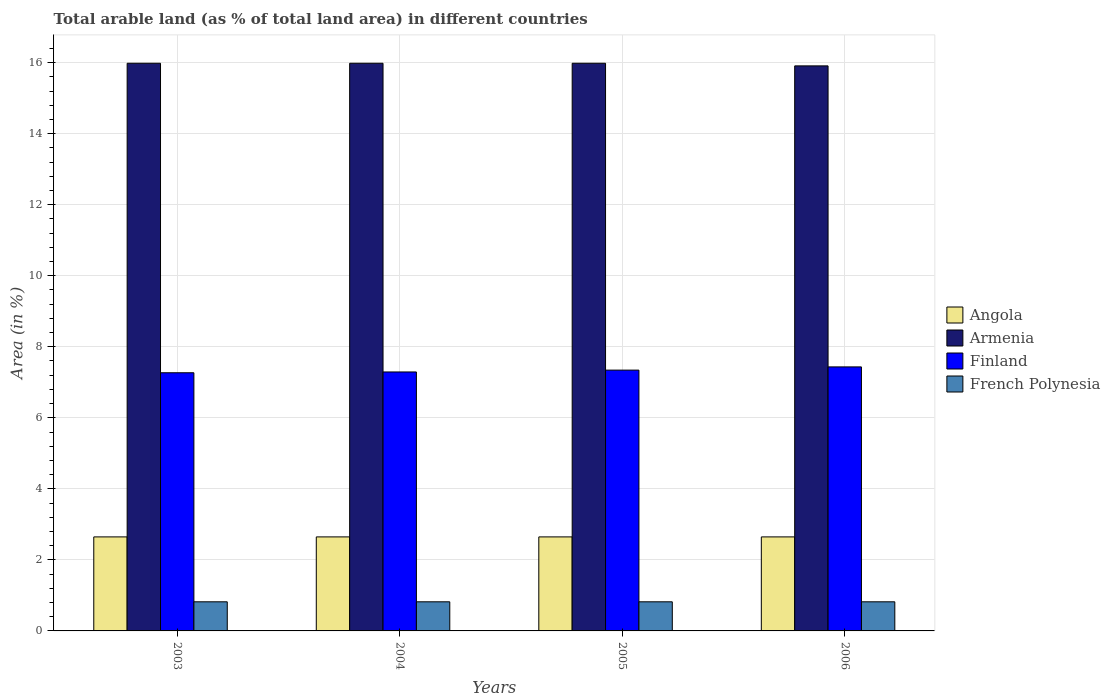Are the number of bars on each tick of the X-axis equal?
Give a very brief answer. Yes. How many bars are there on the 1st tick from the left?
Keep it short and to the point. 4. How many bars are there on the 1st tick from the right?
Ensure brevity in your answer.  4. What is the label of the 4th group of bars from the left?
Offer a terse response. 2006. What is the percentage of arable land in Armenia in 2004?
Keep it short and to the point. 15.98. Across all years, what is the maximum percentage of arable land in Armenia?
Give a very brief answer. 15.98. Across all years, what is the minimum percentage of arable land in French Polynesia?
Give a very brief answer. 0.82. In which year was the percentage of arable land in Armenia minimum?
Ensure brevity in your answer.  2006. What is the total percentage of arable land in French Polynesia in the graph?
Offer a terse response. 3.28. What is the difference between the percentage of arable land in Angola in 2003 and the percentage of arable land in Finland in 2006?
Give a very brief answer. -4.79. What is the average percentage of arable land in Angola per year?
Give a very brief answer. 2.65. In the year 2005, what is the difference between the percentage of arable land in Armenia and percentage of arable land in French Polynesia?
Your answer should be compact. 15.16. What is the ratio of the percentage of arable land in Armenia in 2004 to that in 2005?
Your answer should be very brief. 1. Is the percentage of arable land in French Polynesia in 2003 less than that in 2004?
Make the answer very short. No. Is the difference between the percentage of arable land in Armenia in 2005 and 2006 greater than the difference between the percentage of arable land in French Polynesia in 2005 and 2006?
Provide a short and direct response. Yes. In how many years, is the percentage of arable land in Angola greater than the average percentage of arable land in Angola taken over all years?
Provide a succinct answer. 0. Is it the case that in every year, the sum of the percentage of arable land in Finland and percentage of arable land in Angola is greater than the sum of percentage of arable land in French Polynesia and percentage of arable land in Armenia?
Keep it short and to the point. Yes. What does the 3rd bar from the left in 2006 represents?
Offer a terse response. Finland. What does the 4th bar from the right in 2003 represents?
Offer a terse response. Angola. Is it the case that in every year, the sum of the percentage of arable land in French Polynesia and percentage of arable land in Armenia is greater than the percentage of arable land in Finland?
Offer a very short reply. Yes. Does the graph contain any zero values?
Keep it short and to the point. No. Where does the legend appear in the graph?
Provide a short and direct response. Center right. How many legend labels are there?
Make the answer very short. 4. What is the title of the graph?
Keep it short and to the point. Total arable land (as % of total land area) in different countries. Does "Palau" appear as one of the legend labels in the graph?
Offer a very short reply. No. What is the label or title of the X-axis?
Give a very brief answer. Years. What is the label or title of the Y-axis?
Offer a terse response. Area (in %). What is the Area (in %) in Angola in 2003?
Provide a short and direct response. 2.65. What is the Area (in %) in Armenia in 2003?
Offer a terse response. 15.98. What is the Area (in %) of Finland in 2003?
Your answer should be compact. 7.27. What is the Area (in %) of French Polynesia in 2003?
Your response must be concise. 0.82. What is the Area (in %) of Angola in 2004?
Offer a very short reply. 2.65. What is the Area (in %) in Armenia in 2004?
Offer a terse response. 15.98. What is the Area (in %) of Finland in 2004?
Provide a short and direct response. 7.29. What is the Area (in %) of French Polynesia in 2004?
Your answer should be compact. 0.82. What is the Area (in %) in Angola in 2005?
Provide a succinct answer. 2.65. What is the Area (in %) in Armenia in 2005?
Give a very brief answer. 15.98. What is the Area (in %) in Finland in 2005?
Make the answer very short. 7.34. What is the Area (in %) in French Polynesia in 2005?
Give a very brief answer. 0.82. What is the Area (in %) in Angola in 2006?
Your response must be concise. 2.65. What is the Area (in %) in Armenia in 2006?
Give a very brief answer. 15.91. What is the Area (in %) of Finland in 2006?
Offer a very short reply. 7.43. What is the Area (in %) of French Polynesia in 2006?
Keep it short and to the point. 0.82. Across all years, what is the maximum Area (in %) in Angola?
Provide a short and direct response. 2.65. Across all years, what is the maximum Area (in %) in Armenia?
Your answer should be very brief. 15.98. Across all years, what is the maximum Area (in %) of Finland?
Provide a short and direct response. 7.43. Across all years, what is the maximum Area (in %) in French Polynesia?
Your response must be concise. 0.82. Across all years, what is the minimum Area (in %) of Angola?
Ensure brevity in your answer.  2.65. Across all years, what is the minimum Area (in %) in Armenia?
Provide a short and direct response. 15.91. Across all years, what is the minimum Area (in %) of Finland?
Your answer should be compact. 7.27. Across all years, what is the minimum Area (in %) in French Polynesia?
Your response must be concise. 0.82. What is the total Area (in %) of Angola in the graph?
Ensure brevity in your answer.  10.59. What is the total Area (in %) in Armenia in the graph?
Offer a very short reply. 63.85. What is the total Area (in %) in Finland in the graph?
Give a very brief answer. 29.33. What is the total Area (in %) of French Polynesia in the graph?
Offer a very short reply. 3.28. What is the difference between the Area (in %) of Armenia in 2003 and that in 2004?
Keep it short and to the point. 0. What is the difference between the Area (in %) in Finland in 2003 and that in 2004?
Your answer should be very brief. -0.02. What is the difference between the Area (in %) of French Polynesia in 2003 and that in 2004?
Provide a succinct answer. 0. What is the difference between the Area (in %) in Angola in 2003 and that in 2005?
Give a very brief answer. 0. What is the difference between the Area (in %) of Finland in 2003 and that in 2005?
Your answer should be compact. -0.07. What is the difference between the Area (in %) of French Polynesia in 2003 and that in 2005?
Make the answer very short. 0. What is the difference between the Area (in %) of Armenia in 2003 and that in 2006?
Your answer should be very brief. 0.07. What is the difference between the Area (in %) of Finland in 2003 and that in 2006?
Your answer should be very brief. -0.17. What is the difference between the Area (in %) of French Polynesia in 2003 and that in 2006?
Provide a succinct answer. 0. What is the difference between the Area (in %) in Angola in 2004 and that in 2005?
Offer a very short reply. 0. What is the difference between the Area (in %) of Finland in 2004 and that in 2005?
Your response must be concise. -0.05. What is the difference between the Area (in %) of Armenia in 2004 and that in 2006?
Your answer should be very brief. 0.07. What is the difference between the Area (in %) in Finland in 2004 and that in 2006?
Keep it short and to the point. -0.14. What is the difference between the Area (in %) in French Polynesia in 2004 and that in 2006?
Give a very brief answer. 0. What is the difference between the Area (in %) in Angola in 2005 and that in 2006?
Your answer should be very brief. 0. What is the difference between the Area (in %) of Armenia in 2005 and that in 2006?
Provide a short and direct response. 0.07. What is the difference between the Area (in %) of Finland in 2005 and that in 2006?
Ensure brevity in your answer.  -0.09. What is the difference between the Area (in %) in Angola in 2003 and the Area (in %) in Armenia in 2004?
Make the answer very short. -13.33. What is the difference between the Area (in %) in Angola in 2003 and the Area (in %) in Finland in 2004?
Your answer should be very brief. -4.64. What is the difference between the Area (in %) of Angola in 2003 and the Area (in %) of French Polynesia in 2004?
Provide a short and direct response. 1.83. What is the difference between the Area (in %) of Armenia in 2003 and the Area (in %) of Finland in 2004?
Offer a very short reply. 8.69. What is the difference between the Area (in %) of Armenia in 2003 and the Area (in %) of French Polynesia in 2004?
Your answer should be very brief. 15.16. What is the difference between the Area (in %) of Finland in 2003 and the Area (in %) of French Polynesia in 2004?
Offer a very short reply. 6.45. What is the difference between the Area (in %) in Angola in 2003 and the Area (in %) in Armenia in 2005?
Keep it short and to the point. -13.33. What is the difference between the Area (in %) in Angola in 2003 and the Area (in %) in Finland in 2005?
Make the answer very short. -4.7. What is the difference between the Area (in %) in Angola in 2003 and the Area (in %) in French Polynesia in 2005?
Provide a succinct answer. 1.83. What is the difference between the Area (in %) in Armenia in 2003 and the Area (in %) in Finland in 2005?
Ensure brevity in your answer.  8.64. What is the difference between the Area (in %) of Armenia in 2003 and the Area (in %) of French Polynesia in 2005?
Provide a succinct answer. 15.16. What is the difference between the Area (in %) of Finland in 2003 and the Area (in %) of French Polynesia in 2005?
Your response must be concise. 6.45. What is the difference between the Area (in %) in Angola in 2003 and the Area (in %) in Armenia in 2006?
Offer a terse response. -13.26. What is the difference between the Area (in %) in Angola in 2003 and the Area (in %) in Finland in 2006?
Offer a very short reply. -4.79. What is the difference between the Area (in %) in Angola in 2003 and the Area (in %) in French Polynesia in 2006?
Ensure brevity in your answer.  1.83. What is the difference between the Area (in %) in Armenia in 2003 and the Area (in %) in Finland in 2006?
Keep it short and to the point. 8.55. What is the difference between the Area (in %) of Armenia in 2003 and the Area (in %) of French Polynesia in 2006?
Offer a terse response. 15.16. What is the difference between the Area (in %) of Finland in 2003 and the Area (in %) of French Polynesia in 2006?
Provide a short and direct response. 6.45. What is the difference between the Area (in %) in Angola in 2004 and the Area (in %) in Armenia in 2005?
Keep it short and to the point. -13.33. What is the difference between the Area (in %) in Angola in 2004 and the Area (in %) in Finland in 2005?
Give a very brief answer. -4.7. What is the difference between the Area (in %) of Angola in 2004 and the Area (in %) of French Polynesia in 2005?
Your response must be concise. 1.83. What is the difference between the Area (in %) of Armenia in 2004 and the Area (in %) of Finland in 2005?
Your response must be concise. 8.64. What is the difference between the Area (in %) of Armenia in 2004 and the Area (in %) of French Polynesia in 2005?
Keep it short and to the point. 15.16. What is the difference between the Area (in %) of Finland in 2004 and the Area (in %) of French Polynesia in 2005?
Make the answer very short. 6.47. What is the difference between the Area (in %) in Angola in 2004 and the Area (in %) in Armenia in 2006?
Your response must be concise. -13.26. What is the difference between the Area (in %) in Angola in 2004 and the Area (in %) in Finland in 2006?
Provide a succinct answer. -4.79. What is the difference between the Area (in %) in Angola in 2004 and the Area (in %) in French Polynesia in 2006?
Provide a succinct answer. 1.83. What is the difference between the Area (in %) of Armenia in 2004 and the Area (in %) of Finland in 2006?
Provide a short and direct response. 8.55. What is the difference between the Area (in %) in Armenia in 2004 and the Area (in %) in French Polynesia in 2006?
Offer a terse response. 15.16. What is the difference between the Area (in %) of Finland in 2004 and the Area (in %) of French Polynesia in 2006?
Ensure brevity in your answer.  6.47. What is the difference between the Area (in %) in Angola in 2005 and the Area (in %) in Armenia in 2006?
Your response must be concise. -13.26. What is the difference between the Area (in %) in Angola in 2005 and the Area (in %) in Finland in 2006?
Give a very brief answer. -4.79. What is the difference between the Area (in %) of Angola in 2005 and the Area (in %) of French Polynesia in 2006?
Ensure brevity in your answer.  1.83. What is the difference between the Area (in %) of Armenia in 2005 and the Area (in %) of Finland in 2006?
Offer a very short reply. 8.55. What is the difference between the Area (in %) in Armenia in 2005 and the Area (in %) in French Polynesia in 2006?
Your answer should be compact. 15.16. What is the difference between the Area (in %) of Finland in 2005 and the Area (in %) of French Polynesia in 2006?
Offer a very short reply. 6.52. What is the average Area (in %) of Angola per year?
Your answer should be very brief. 2.65. What is the average Area (in %) in Armenia per year?
Offer a terse response. 15.96. What is the average Area (in %) of Finland per year?
Your answer should be very brief. 7.33. What is the average Area (in %) of French Polynesia per year?
Offer a very short reply. 0.82. In the year 2003, what is the difference between the Area (in %) of Angola and Area (in %) of Armenia?
Provide a short and direct response. -13.33. In the year 2003, what is the difference between the Area (in %) in Angola and Area (in %) in Finland?
Your answer should be very brief. -4.62. In the year 2003, what is the difference between the Area (in %) in Angola and Area (in %) in French Polynesia?
Provide a short and direct response. 1.83. In the year 2003, what is the difference between the Area (in %) of Armenia and Area (in %) of Finland?
Ensure brevity in your answer.  8.71. In the year 2003, what is the difference between the Area (in %) in Armenia and Area (in %) in French Polynesia?
Your response must be concise. 15.16. In the year 2003, what is the difference between the Area (in %) in Finland and Area (in %) in French Polynesia?
Provide a short and direct response. 6.45. In the year 2004, what is the difference between the Area (in %) in Angola and Area (in %) in Armenia?
Keep it short and to the point. -13.33. In the year 2004, what is the difference between the Area (in %) of Angola and Area (in %) of Finland?
Keep it short and to the point. -4.64. In the year 2004, what is the difference between the Area (in %) in Angola and Area (in %) in French Polynesia?
Offer a terse response. 1.83. In the year 2004, what is the difference between the Area (in %) of Armenia and Area (in %) of Finland?
Make the answer very short. 8.69. In the year 2004, what is the difference between the Area (in %) of Armenia and Area (in %) of French Polynesia?
Give a very brief answer. 15.16. In the year 2004, what is the difference between the Area (in %) in Finland and Area (in %) in French Polynesia?
Give a very brief answer. 6.47. In the year 2005, what is the difference between the Area (in %) in Angola and Area (in %) in Armenia?
Provide a short and direct response. -13.33. In the year 2005, what is the difference between the Area (in %) of Angola and Area (in %) of Finland?
Make the answer very short. -4.7. In the year 2005, what is the difference between the Area (in %) of Angola and Area (in %) of French Polynesia?
Offer a terse response. 1.83. In the year 2005, what is the difference between the Area (in %) of Armenia and Area (in %) of Finland?
Give a very brief answer. 8.64. In the year 2005, what is the difference between the Area (in %) of Armenia and Area (in %) of French Polynesia?
Your answer should be very brief. 15.16. In the year 2005, what is the difference between the Area (in %) of Finland and Area (in %) of French Polynesia?
Give a very brief answer. 6.52. In the year 2006, what is the difference between the Area (in %) of Angola and Area (in %) of Armenia?
Offer a terse response. -13.26. In the year 2006, what is the difference between the Area (in %) of Angola and Area (in %) of Finland?
Provide a succinct answer. -4.79. In the year 2006, what is the difference between the Area (in %) in Angola and Area (in %) in French Polynesia?
Offer a very short reply. 1.83. In the year 2006, what is the difference between the Area (in %) of Armenia and Area (in %) of Finland?
Provide a succinct answer. 8.47. In the year 2006, what is the difference between the Area (in %) in Armenia and Area (in %) in French Polynesia?
Your answer should be very brief. 15.09. In the year 2006, what is the difference between the Area (in %) of Finland and Area (in %) of French Polynesia?
Make the answer very short. 6.61. What is the ratio of the Area (in %) of French Polynesia in 2003 to that in 2004?
Ensure brevity in your answer.  1. What is the ratio of the Area (in %) of Armenia in 2003 to that in 2005?
Offer a terse response. 1. What is the ratio of the Area (in %) of Finland in 2003 to that in 2005?
Provide a succinct answer. 0.99. What is the ratio of the Area (in %) in Armenia in 2003 to that in 2006?
Provide a short and direct response. 1. What is the ratio of the Area (in %) in Finland in 2003 to that in 2006?
Give a very brief answer. 0.98. What is the ratio of the Area (in %) of French Polynesia in 2003 to that in 2006?
Your answer should be very brief. 1. What is the ratio of the Area (in %) in Finland in 2004 to that in 2005?
Ensure brevity in your answer.  0.99. What is the ratio of the Area (in %) of French Polynesia in 2004 to that in 2005?
Offer a terse response. 1. What is the ratio of the Area (in %) of Finland in 2004 to that in 2006?
Offer a very short reply. 0.98. What is the ratio of the Area (in %) of French Polynesia in 2005 to that in 2006?
Give a very brief answer. 1. What is the difference between the highest and the second highest Area (in %) of Finland?
Your response must be concise. 0.09. What is the difference between the highest and the second highest Area (in %) of French Polynesia?
Keep it short and to the point. 0. What is the difference between the highest and the lowest Area (in %) of Angola?
Ensure brevity in your answer.  0. What is the difference between the highest and the lowest Area (in %) of Armenia?
Your answer should be very brief. 0.07. What is the difference between the highest and the lowest Area (in %) of Finland?
Give a very brief answer. 0.17. 